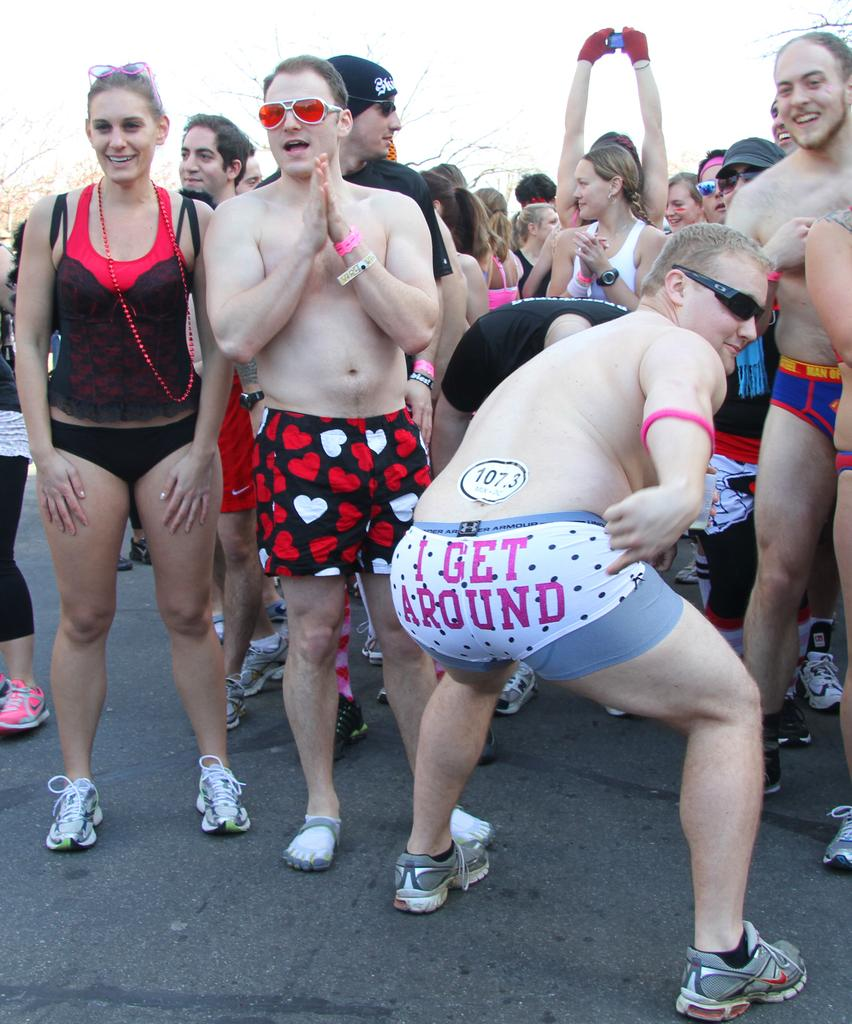Who or what can be seen in the image? There are people in the image. What are the people wearing? The people are wearing clothes. What is visible at the top of the image? The sky is visible at the top of the image. Where is the throne located in the image? There is no throne present in the image. What type of lock is used to secure the people in the image? There is no lock present in the image, and the people are not secured. 